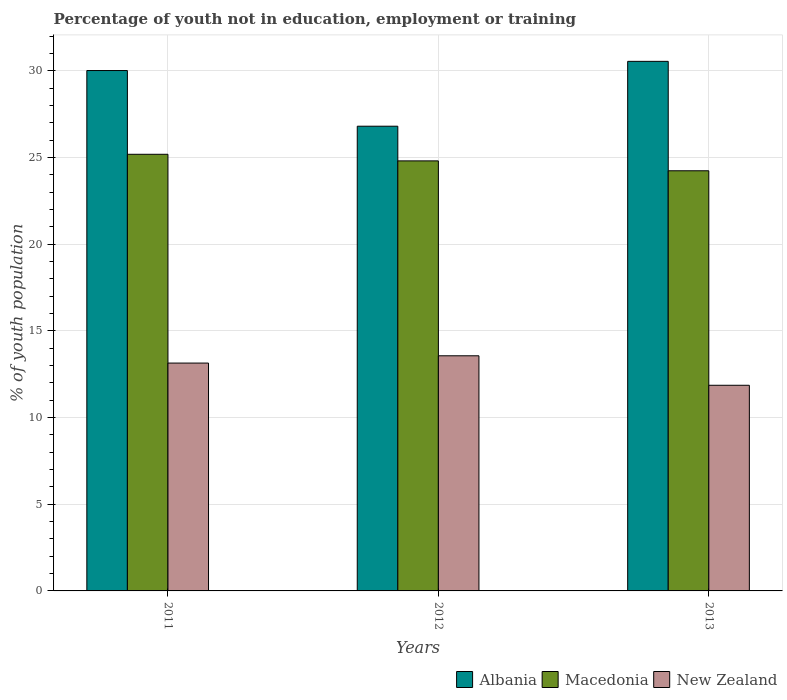Are the number of bars on each tick of the X-axis equal?
Offer a terse response. Yes. How many bars are there on the 2nd tick from the left?
Offer a very short reply. 3. How many bars are there on the 1st tick from the right?
Ensure brevity in your answer.  3. What is the label of the 1st group of bars from the left?
Ensure brevity in your answer.  2011. What is the percentage of unemployed youth population in in Albania in 2012?
Give a very brief answer. 26.8. Across all years, what is the maximum percentage of unemployed youth population in in Albania?
Offer a very short reply. 30.54. Across all years, what is the minimum percentage of unemployed youth population in in Macedonia?
Keep it short and to the point. 24.23. What is the total percentage of unemployed youth population in in Macedonia in the graph?
Make the answer very short. 74.21. What is the difference between the percentage of unemployed youth population in in Albania in 2012 and that in 2013?
Ensure brevity in your answer.  -3.74. What is the difference between the percentage of unemployed youth population in in Albania in 2011 and the percentage of unemployed youth population in in Macedonia in 2012?
Ensure brevity in your answer.  5.21. What is the average percentage of unemployed youth population in in Macedonia per year?
Provide a succinct answer. 24.74. In the year 2011, what is the difference between the percentage of unemployed youth population in in Albania and percentage of unemployed youth population in in Macedonia?
Ensure brevity in your answer.  4.83. In how many years, is the percentage of unemployed youth population in in Albania greater than 7 %?
Keep it short and to the point. 3. What is the ratio of the percentage of unemployed youth population in in New Zealand in 2011 to that in 2012?
Your response must be concise. 0.97. Is the percentage of unemployed youth population in in Macedonia in 2011 less than that in 2012?
Provide a short and direct response. No. Is the difference between the percentage of unemployed youth population in in Albania in 2011 and 2013 greater than the difference between the percentage of unemployed youth population in in Macedonia in 2011 and 2013?
Provide a succinct answer. No. What is the difference between the highest and the second highest percentage of unemployed youth population in in New Zealand?
Ensure brevity in your answer.  0.42. What is the difference between the highest and the lowest percentage of unemployed youth population in in Albania?
Your answer should be very brief. 3.74. What does the 3rd bar from the left in 2011 represents?
Make the answer very short. New Zealand. What does the 2nd bar from the right in 2013 represents?
Give a very brief answer. Macedonia. Is it the case that in every year, the sum of the percentage of unemployed youth population in in Macedonia and percentage of unemployed youth population in in Albania is greater than the percentage of unemployed youth population in in New Zealand?
Provide a short and direct response. Yes. Are all the bars in the graph horizontal?
Make the answer very short. No. How many years are there in the graph?
Make the answer very short. 3. What is the difference between two consecutive major ticks on the Y-axis?
Your answer should be compact. 5. Where does the legend appear in the graph?
Provide a short and direct response. Bottom right. How many legend labels are there?
Keep it short and to the point. 3. What is the title of the graph?
Make the answer very short. Percentage of youth not in education, employment or training. What is the label or title of the X-axis?
Provide a succinct answer. Years. What is the label or title of the Y-axis?
Provide a short and direct response. % of youth population. What is the % of youth population of Albania in 2011?
Offer a very short reply. 30.01. What is the % of youth population in Macedonia in 2011?
Offer a very short reply. 25.18. What is the % of youth population in New Zealand in 2011?
Ensure brevity in your answer.  13.14. What is the % of youth population of Albania in 2012?
Ensure brevity in your answer.  26.8. What is the % of youth population of Macedonia in 2012?
Keep it short and to the point. 24.8. What is the % of youth population in New Zealand in 2012?
Your answer should be very brief. 13.56. What is the % of youth population of Albania in 2013?
Give a very brief answer. 30.54. What is the % of youth population in Macedonia in 2013?
Offer a very short reply. 24.23. What is the % of youth population of New Zealand in 2013?
Offer a very short reply. 11.86. Across all years, what is the maximum % of youth population of Albania?
Make the answer very short. 30.54. Across all years, what is the maximum % of youth population of Macedonia?
Your answer should be compact. 25.18. Across all years, what is the maximum % of youth population of New Zealand?
Keep it short and to the point. 13.56. Across all years, what is the minimum % of youth population of Albania?
Ensure brevity in your answer.  26.8. Across all years, what is the minimum % of youth population of Macedonia?
Give a very brief answer. 24.23. Across all years, what is the minimum % of youth population of New Zealand?
Make the answer very short. 11.86. What is the total % of youth population in Albania in the graph?
Offer a very short reply. 87.35. What is the total % of youth population in Macedonia in the graph?
Provide a short and direct response. 74.21. What is the total % of youth population of New Zealand in the graph?
Offer a very short reply. 38.56. What is the difference between the % of youth population of Albania in 2011 and that in 2012?
Your answer should be very brief. 3.21. What is the difference between the % of youth population in Macedonia in 2011 and that in 2012?
Keep it short and to the point. 0.38. What is the difference between the % of youth population of New Zealand in 2011 and that in 2012?
Provide a short and direct response. -0.42. What is the difference between the % of youth population in Albania in 2011 and that in 2013?
Make the answer very short. -0.53. What is the difference between the % of youth population in New Zealand in 2011 and that in 2013?
Offer a very short reply. 1.28. What is the difference between the % of youth population in Albania in 2012 and that in 2013?
Your answer should be very brief. -3.74. What is the difference between the % of youth population of Macedonia in 2012 and that in 2013?
Provide a short and direct response. 0.57. What is the difference between the % of youth population of Albania in 2011 and the % of youth population of Macedonia in 2012?
Your answer should be very brief. 5.21. What is the difference between the % of youth population in Albania in 2011 and the % of youth population in New Zealand in 2012?
Provide a succinct answer. 16.45. What is the difference between the % of youth population in Macedonia in 2011 and the % of youth population in New Zealand in 2012?
Make the answer very short. 11.62. What is the difference between the % of youth population of Albania in 2011 and the % of youth population of Macedonia in 2013?
Your answer should be very brief. 5.78. What is the difference between the % of youth population in Albania in 2011 and the % of youth population in New Zealand in 2013?
Your response must be concise. 18.15. What is the difference between the % of youth population of Macedonia in 2011 and the % of youth population of New Zealand in 2013?
Keep it short and to the point. 13.32. What is the difference between the % of youth population of Albania in 2012 and the % of youth population of Macedonia in 2013?
Ensure brevity in your answer.  2.57. What is the difference between the % of youth population in Albania in 2012 and the % of youth population in New Zealand in 2013?
Ensure brevity in your answer.  14.94. What is the difference between the % of youth population of Macedonia in 2012 and the % of youth population of New Zealand in 2013?
Provide a short and direct response. 12.94. What is the average % of youth population of Albania per year?
Offer a very short reply. 29.12. What is the average % of youth population of Macedonia per year?
Offer a terse response. 24.74. What is the average % of youth population in New Zealand per year?
Provide a succinct answer. 12.85. In the year 2011, what is the difference between the % of youth population in Albania and % of youth population in Macedonia?
Your answer should be compact. 4.83. In the year 2011, what is the difference between the % of youth population in Albania and % of youth population in New Zealand?
Give a very brief answer. 16.87. In the year 2011, what is the difference between the % of youth population in Macedonia and % of youth population in New Zealand?
Offer a terse response. 12.04. In the year 2012, what is the difference between the % of youth population of Albania and % of youth population of New Zealand?
Provide a succinct answer. 13.24. In the year 2012, what is the difference between the % of youth population in Macedonia and % of youth population in New Zealand?
Offer a terse response. 11.24. In the year 2013, what is the difference between the % of youth population of Albania and % of youth population of Macedonia?
Offer a terse response. 6.31. In the year 2013, what is the difference between the % of youth population of Albania and % of youth population of New Zealand?
Provide a short and direct response. 18.68. In the year 2013, what is the difference between the % of youth population of Macedonia and % of youth population of New Zealand?
Provide a short and direct response. 12.37. What is the ratio of the % of youth population of Albania in 2011 to that in 2012?
Give a very brief answer. 1.12. What is the ratio of the % of youth population of Macedonia in 2011 to that in 2012?
Ensure brevity in your answer.  1.02. What is the ratio of the % of youth population of Albania in 2011 to that in 2013?
Make the answer very short. 0.98. What is the ratio of the % of youth population of Macedonia in 2011 to that in 2013?
Give a very brief answer. 1.04. What is the ratio of the % of youth population in New Zealand in 2011 to that in 2013?
Make the answer very short. 1.11. What is the ratio of the % of youth population of Albania in 2012 to that in 2013?
Your answer should be compact. 0.88. What is the ratio of the % of youth population in Macedonia in 2012 to that in 2013?
Keep it short and to the point. 1.02. What is the ratio of the % of youth population in New Zealand in 2012 to that in 2013?
Provide a short and direct response. 1.14. What is the difference between the highest and the second highest % of youth population of Albania?
Offer a very short reply. 0.53. What is the difference between the highest and the second highest % of youth population of Macedonia?
Offer a terse response. 0.38. What is the difference between the highest and the second highest % of youth population in New Zealand?
Keep it short and to the point. 0.42. What is the difference between the highest and the lowest % of youth population of Albania?
Provide a short and direct response. 3.74. What is the difference between the highest and the lowest % of youth population of New Zealand?
Your answer should be compact. 1.7. 